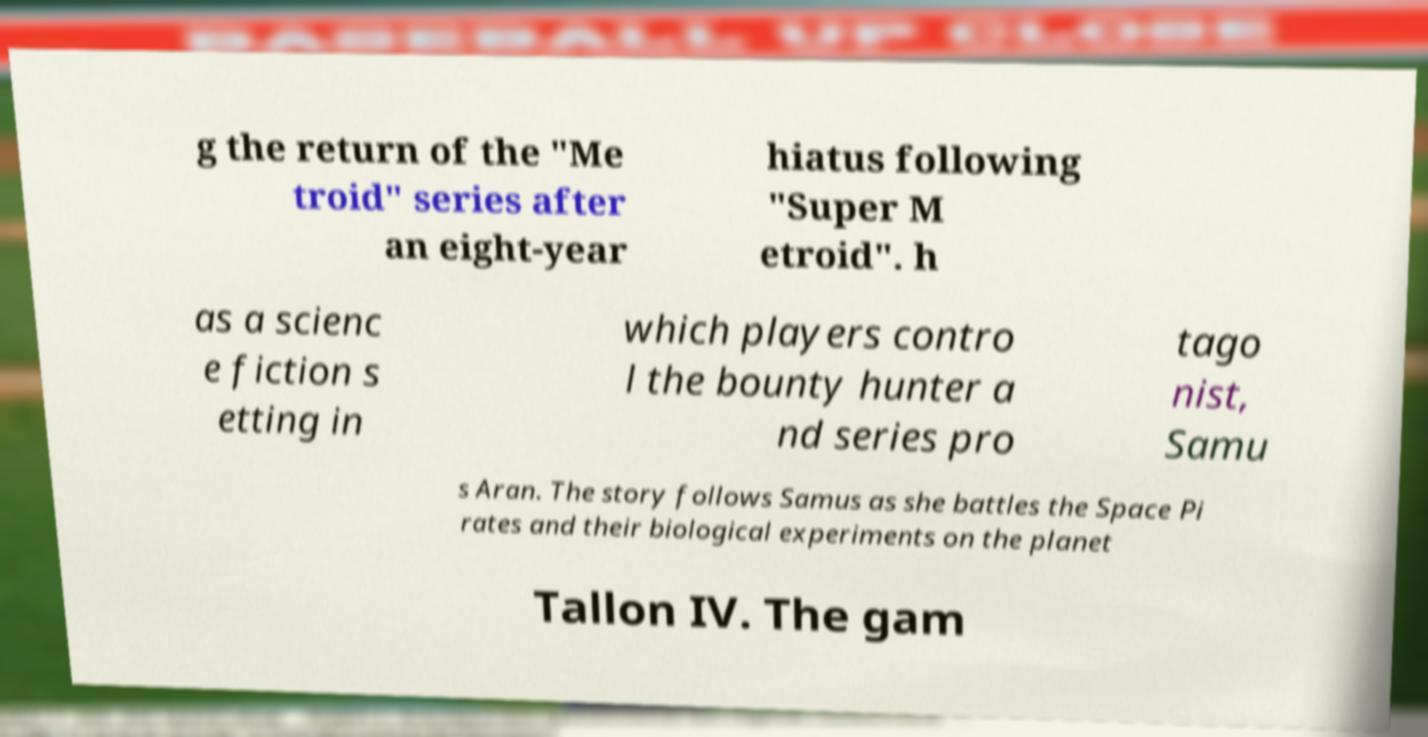Please identify and transcribe the text found in this image. g the return of the "Me troid" series after an eight-year hiatus following "Super M etroid". h as a scienc e fiction s etting in which players contro l the bounty hunter a nd series pro tago nist, Samu s Aran. The story follows Samus as she battles the Space Pi rates and their biological experiments on the planet Tallon IV. The gam 